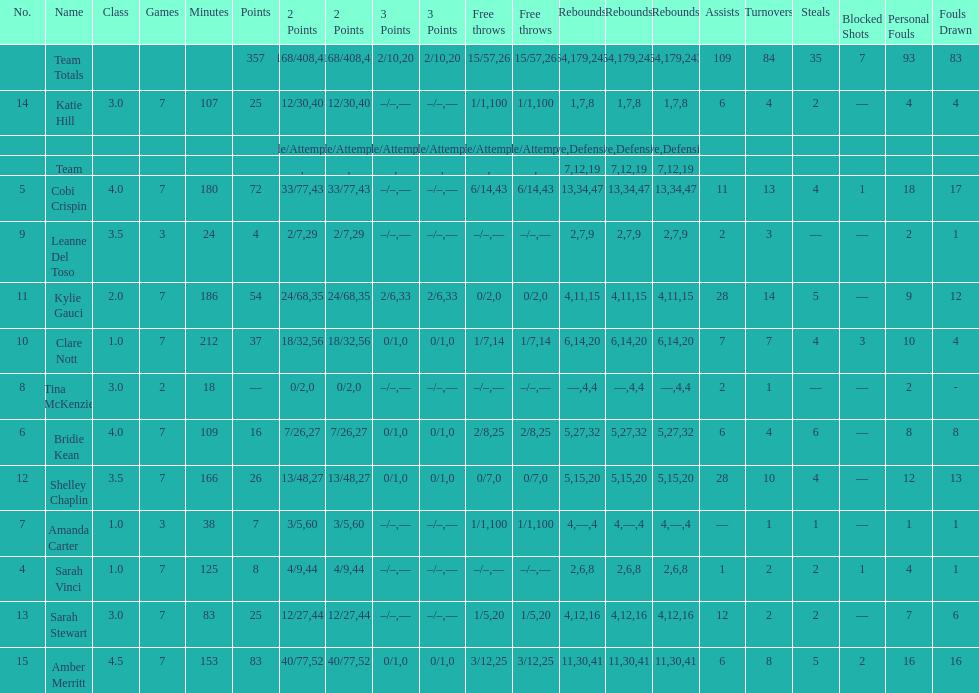Who is the last player on the list to not attempt a 3 point shot? Katie Hill. 